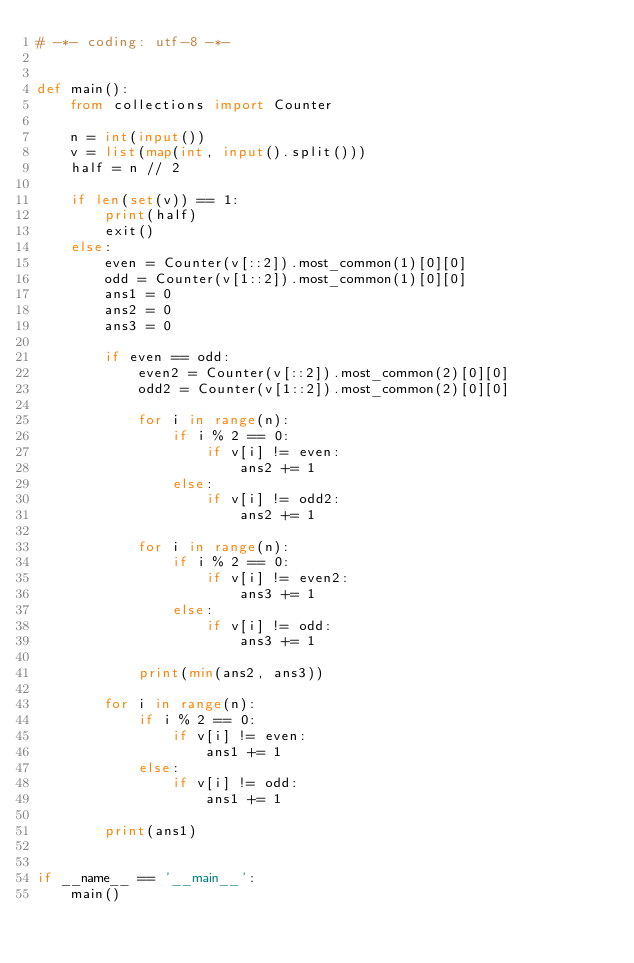Convert code to text. <code><loc_0><loc_0><loc_500><loc_500><_Python_># -*- coding: utf-8 -*-


def main():
    from collections import Counter

    n = int(input())
    v = list(map(int, input().split()))
    half = n // 2

    if len(set(v)) == 1:
        print(half)
        exit()
    else:
        even = Counter(v[::2]).most_common(1)[0][0]
        odd = Counter(v[1::2]).most_common(1)[0][0]
        ans1 = 0
        ans2 = 0
        ans3 = 0

        if even == odd:
            even2 = Counter(v[::2]).most_common(2)[0][0]
            odd2 = Counter(v[1::2]).most_common(2)[0][0]

            for i in range(n):
                if i % 2 == 0:
                    if v[i] != even:
                        ans2 += 1
                else:
                    if v[i] != odd2:
                        ans2 += 1

            for i in range(n):
                if i % 2 == 0:
                    if v[i] != even2:
                        ans3 += 1
                else:
                    if v[i] != odd:
                        ans3 += 1

            print(min(ans2, ans3))

        for i in range(n):
            if i % 2 == 0:
                if v[i] != even:
                    ans1 += 1
            else:
                if v[i] != odd:
                    ans1 += 1

        print(ans1)


if __name__ == '__main__':
    main()
</code> 